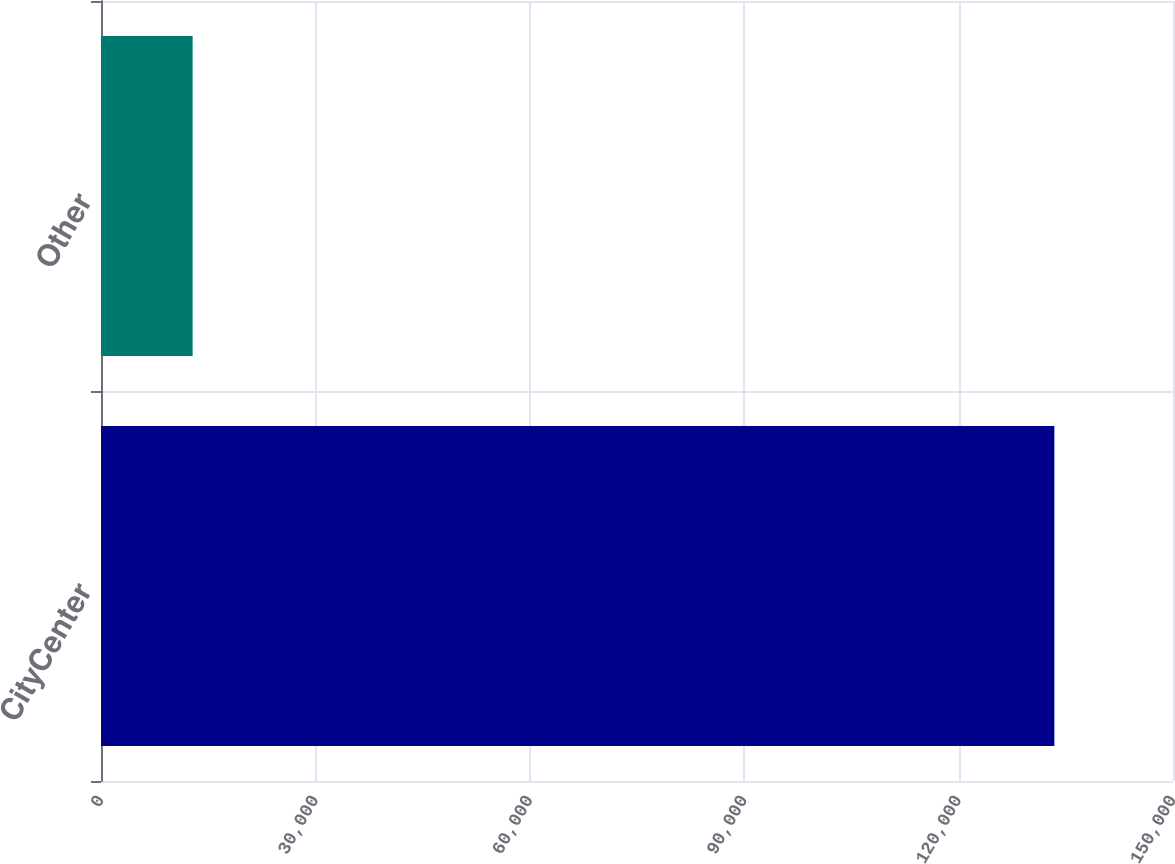Convert chart. <chart><loc_0><loc_0><loc_500><loc_500><bar_chart><fcel>CityCenter<fcel>Other<nl><fcel>133400<fcel>12822<nl></chart> 